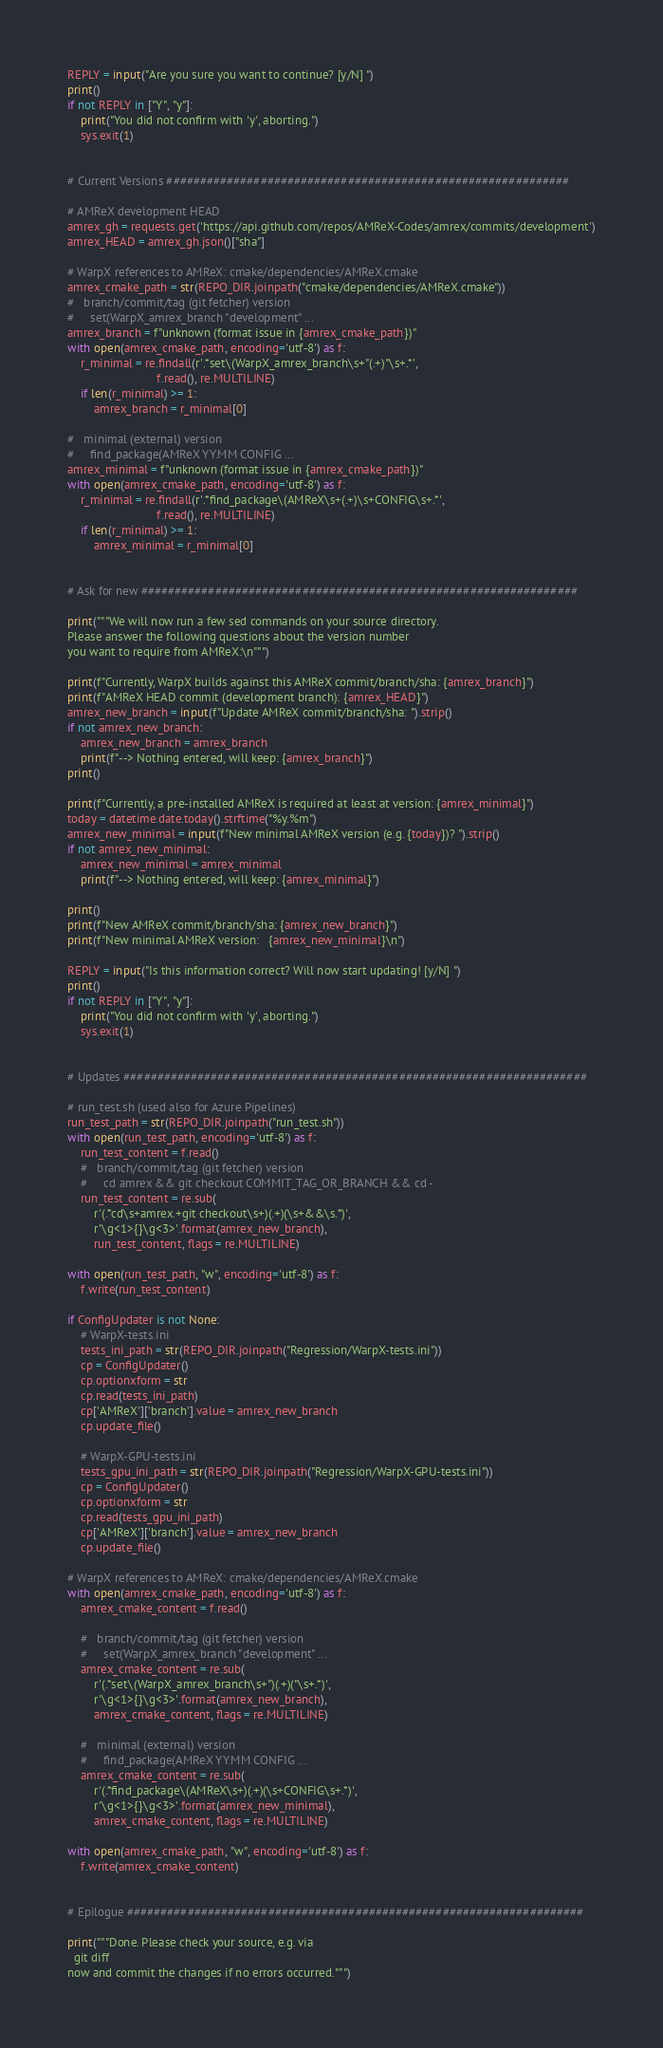Convert code to text. <code><loc_0><loc_0><loc_500><loc_500><_Python_>
REPLY = input("Are you sure you want to continue? [y/N] ")
print()
if not REPLY in ["Y", "y"]:
    print("You did not confirm with 'y', aborting.")
    sys.exit(1)


# Current Versions ############################################################

# AMReX development HEAD
amrex_gh = requests.get('https://api.github.com/repos/AMReX-Codes/amrex/commits/development')
amrex_HEAD = amrex_gh.json()["sha"]

# WarpX references to AMReX: cmake/dependencies/AMReX.cmake
amrex_cmake_path = str(REPO_DIR.joinpath("cmake/dependencies/AMReX.cmake"))
#   branch/commit/tag (git fetcher) version
#     set(WarpX_amrex_branch "development" ...
amrex_branch = f"unknown (format issue in {amrex_cmake_path})"
with open(amrex_cmake_path, encoding='utf-8') as f:
    r_minimal = re.findall(r'.*set\(WarpX_amrex_branch\s+"(.+)"\s+.*',
                           f.read(), re.MULTILINE)
    if len(r_minimal) >= 1:
        amrex_branch = r_minimal[0]

#   minimal (external) version
#     find_package(AMReX YY.MM CONFIG ...
amrex_minimal = f"unknown (format issue in {amrex_cmake_path})"
with open(amrex_cmake_path, encoding='utf-8') as f:
    r_minimal = re.findall(r'.*find_package\(AMReX\s+(.+)\s+CONFIG\s+.*',
                           f.read(), re.MULTILINE)
    if len(r_minimal) >= 1:
        amrex_minimal = r_minimal[0]


# Ask for new #################################################################

print("""We will now run a few sed commands on your source directory.
Please answer the following questions about the version number
you want to require from AMReX:\n""")

print(f"Currently, WarpX builds against this AMReX commit/branch/sha: {amrex_branch}")
print(f"AMReX HEAD commit (development branch): {amrex_HEAD}")
amrex_new_branch = input(f"Update AMReX commit/branch/sha: ").strip()
if not amrex_new_branch:
    amrex_new_branch = amrex_branch
    print(f"--> Nothing entered, will keep: {amrex_branch}")
print()

print(f"Currently, a pre-installed AMReX is required at least at version: {amrex_minimal}")
today = datetime.date.today().strftime("%y.%m")
amrex_new_minimal = input(f"New minimal AMReX version (e.g. {today})? ").strip()
if not amrex_new_minimal:
    amrex_new_minimal = amrex_minimal
    print(f"--> Nothing entered, will keep: {amrex_minimal}")

print()
print(f"New AMReX commit/branch/sha: {amrex_new_branch}")
print(f"New minimal AMReX version:   {amrex_new_minimal}\n")

REPLY = input("Is this information correct? Will now start updating! [y/N] ")
print()
if not REPLY in ["Y", "y"]:
    print("You did not confirm with 'y', aborting.")
    sys.exit(1)


# Updates #####################################################################

# run_test.sh (used also for Azure Pipelines)
run_test_path = str(REPO_DIR.joinpath("run_test.sh"))
with open(run_test_path, encoding='utf-8') as f:
    run_test_content = f.read()
    #   branch/commit/tag (git fetcher) version
    #     cd amrex && git checkout COMMIT_TAG_OR_BRANCH && cd -
    run_test_content = re.sub(
        r'(.*cd\s+amrex.+git checkout\s+)(.+)(\s+&&\s.*)',
        r'\g<1>{}\g<3>'.format(amrex_new_branch),
        run_test_content, flags = re.MULTILINE)

with open(run_test_path, "w", encoding='utf-8') as f:
    f.write(run_test_content)

if ConfigUpdater is not None:
    # WarpX-tests.ini
    tests_ini_path = str(REPO_DIR.joinpath("Regression/WarpX-tests.ini"))
    cp = ConfigUpdater()
    cp.optionxform = str
    cp.read(tests_ini_path)
    cp['AMReX']['branch'].value = amrex_new_branch
    cp.update_file()

    # WarpX-GPU-tests.ini
    tests_gpu_ini_path = str(REPO_DIR.joinpath("Regression/WarpX-GPU-tests.ini"))
    cp = ConfigUpdater()
    cp.optionxform = str
    cp.read(tests_gpu_ini_path)
    cp['AMReX']['branch'].value = amrex_new_branch
    cp.update_file()

# WarpX references to AMReX: cmake/dependencies/AMReX.cmake
with open(amrex_cmake_path, encoding='utf-8') as f:
    amrex_cmake_content = f.read()

    #   branch/commit/tag (git fetcher) version
    #     set(WarpX_amrex_branch "development" ...
    amrex_cmake_content = re.sub(
        r'(.*set\(WarpX_amrex_branch\s+")(.+)("\s+.*)',
        r'\g<1>{}\g<3>'.format(amrex_new_branch),
        amrex_cmake_content, flags = re.MULTILINE)

    #   minimal (external) version
    #     find_package(AMReX YY.MM CONFIG ...
    amrex_cmake_content = re.sub(
        r'(.*find_package\(AMReX\s+)(.+)(\s+CONFIG\s+.*)',
        r'\g<1>{}\g<3>'.format(amrex_new_minimal),
        amrex_cmake_content, flags = re.MULTILINE)

with open(amrex_cmake_path, "w", encoding='utf-8') as f:
    f.write(amrex_cmake_content)


# Epilogue ####################################################################

print("""Done. Please check your source, e.g. via
  git diff
now and commit the changes if no errors occurred.""")
</code> 